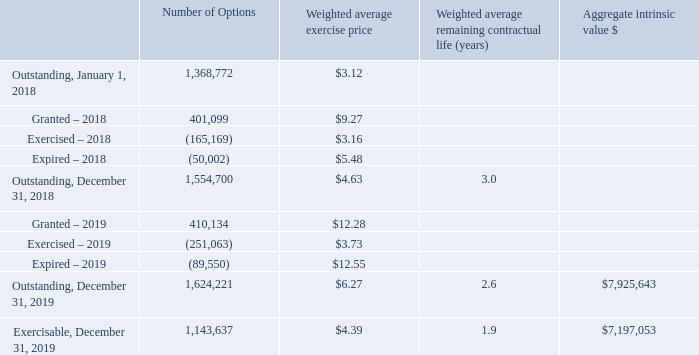NOTE 11 – STOCK COMPENSATION
The Company sponsors a stock-based incentive compensation plan known as the 2013 Equity Compensation Plan (the “Plan”), which was established by the Board of Directors of the Company in June 2013. A total of 500,000 shares were initially reserved for issuance under the Plan. The Plan was amended several times since then to eventually increase the authorized shares to 2,500,000 as of December 31, 2019. A total of 1,624,221 shares of common stock underlying options were outstanding at December 31, 2019. The Company had 236,614 remaining shares available to grant under the Plan at December 31, 2019.
The Plan allows the Company to grant incentive stock options, non-qualified stock options, stock appreciation rights, or restricted stock. The incentive stock options are exercisable for up to ten years, at an option price per share not less than the fair market value on the date the option is granted. The incentive stock options are limited to persons who are regular full-time employees of the Company at the date of the grant of the option. Non-qualified options may be granted to any person, including, but not limited to, employees, independent agents, consultants and attorneys, who the Company’s Board or Compensation Committee believes have contributed, or will contribute, to the success of the Company. Non-qualified options may be issued at option prices of less than fair market value on the date of grant and may be exercisable for up to ten years from date of grant. The option vesting schedule for options granted is determined by the Compensation Committee of the Board of Directors at the time of the grant. The Plan provides for accelerated vesting of unvested options if there is a change in control, as defined in the Plan.
The compensation cost that has been charged against income related to options for the years ended December 31, 2019 and 2018, was $1,687,745 and $1,317,904, respectively. No income tax benefit was recognized in the income statement and no compensation was capitalized in any of the years presented.
The Company had the following option activity during the years ended December 31, 2019 and 2018:
Of the options outstanding at December 31, 2019, 1,143,637 were exercisable with a weighted average contractual life of 1.9 years.
How much was the aggregate intrinsic value of exercisable options in 2019? $7,197,053. What is the proportion of exercisable options over outstanding options for the year ended in December 31, 2019? 1,143,637/1,624,221 
Answer: 0.7. What is the total price of exercised or expired options during the fiscal year 2019? (251,063*3.73)+(89,550*12.55) 
Answer: 2060317.49. What is the percentage change in the number of shares outstanding at the end of 2018 compared to the start of 2018?
Answer scale should be: percent. (1,554,700-1,368,772)/1,368,772 
Answer: 13.58. How much were the compensation costs that have been charged against income related to options in 2018 and 2019, respectively? $1,317,904, $1,687,745. How many remaining shares are available to grant under the Plan on December 31, 2019? 236,614. 